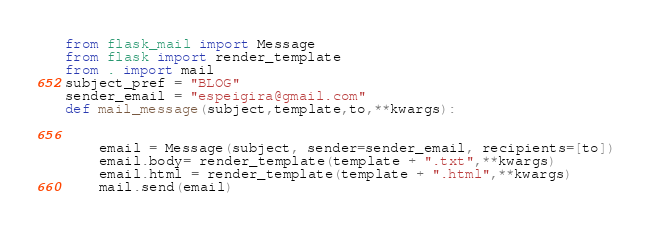Convert code to text. <code><loc_0><loc_0><loc_500><loc_500><_Python_>from flask_mail import Message
from flask import render_template
from . import mail
subject_pref = "BLOG"
sender_email = "espeigira@gmail.com"
def mail_message(subject,template,to,**kwargs):
    

    email = Message(subject, sender=sender_email, recipients=[to])
    email.body= render_template(template + ".txt",**kwargs)
    email.html = render_template(template + ".html",**kwargs)
    mail.send(email)
</code> 